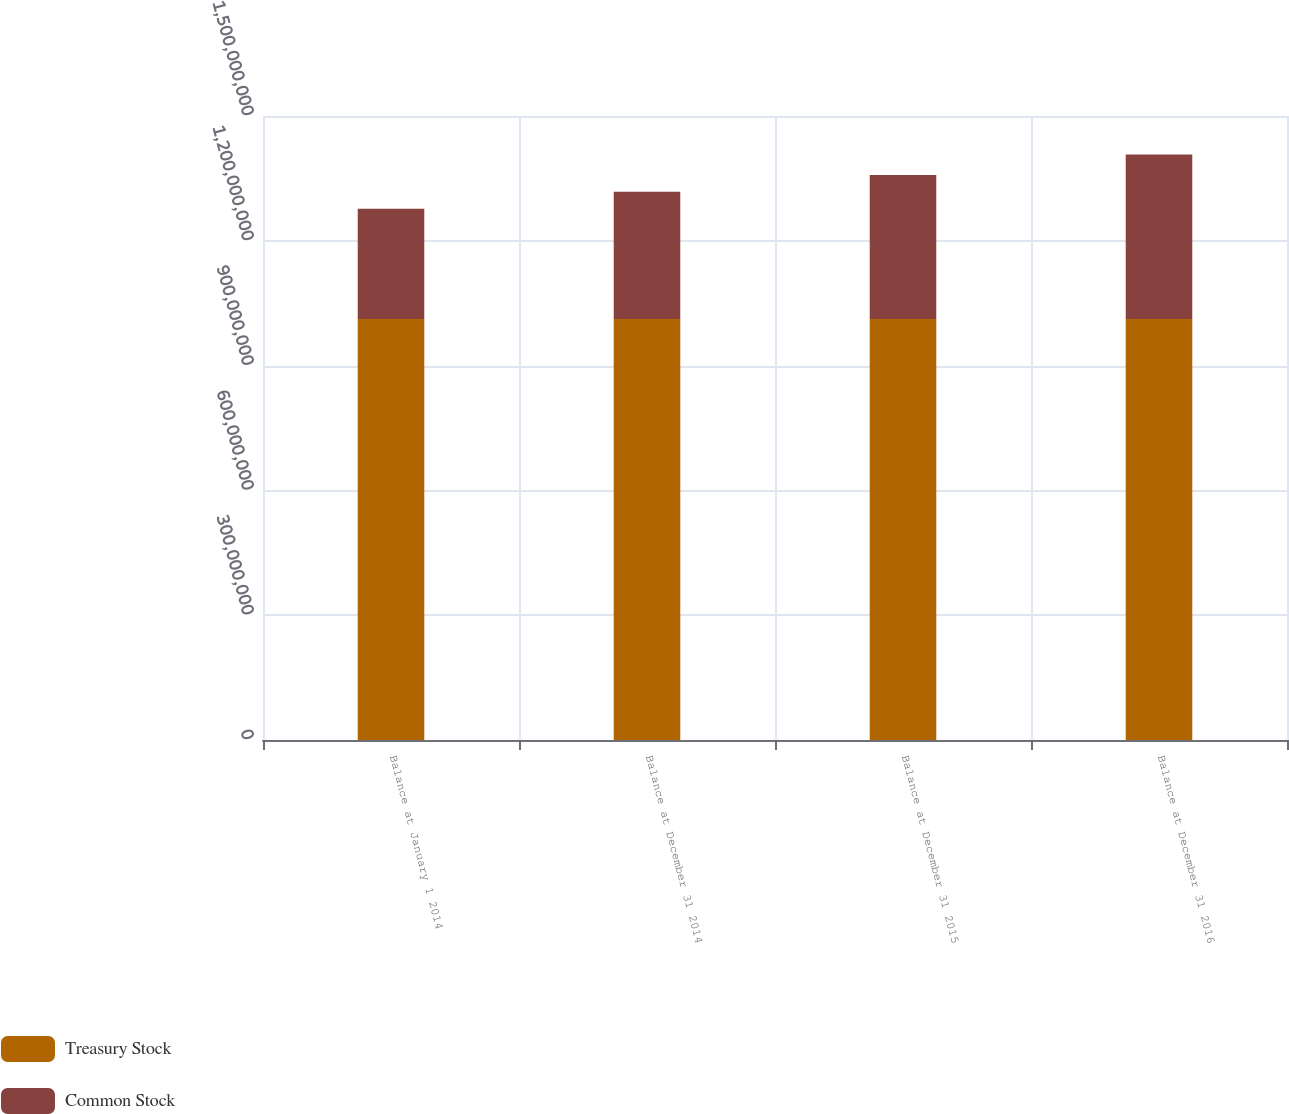Convert chart to OTSL. <chart><loc_0><loc_0><loc_500><loc_500><stacked_bar_chart><ecel><fcel>Balance at January 1 2014<fcel>Balance at December 31 2014<fcel>Balance at December 31 2015<fcel>Balance at December 31 2016<nl><fcel>Treasury Stock<fcel>1.01226e+09<fcel>1.01226e+09<fcel>1.01226e+09<fcel>1.01226e+09<nl><fcel>Common Stock<fcel>2.64882e+08<fcel>3.05534e+08<fcel>3.45637e+08<fcel>3.9511e+08<nl></chart> 